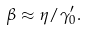<formula> <loc_0><loc_0><loc_500><loc_500>\beta \approx \eta / \gamma _ { 0 } ^ { \prime } .</formula> 